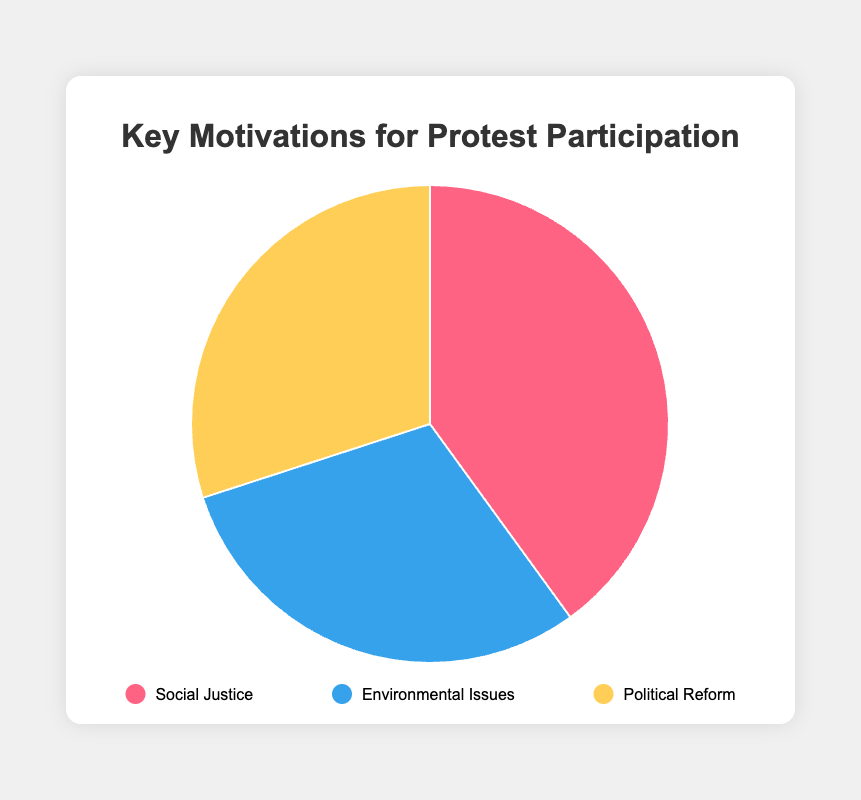Which motivation has the highest percentage? The figure shows three motivations represented by differently sized slices of the pie. The largest slice corresponds to Social Justice with 40%.
Answer: Social Justice What percentage of participants are motivated by Environmental Issues and Political Reform combined? We add the percentages of Environmental Issues (30%) and Political Reform (30%). 30% + 30% = 60%
Answer: 60% Which two motivations have equal percentages? By looking at the pie chart, we can see that the slices for Environmental Issues and Political Reform are the same size, representing equal percentages of 30% each.
Answer: Environmental Issues and Political Reform How much larger is the percentage for Social Justice compared to Environmental Issues? The Social Justice pie slice is 40%, and the Environmental Issues slice is 30%. The difference is 40% - 30% = 10%.
Answer: 10% What is the smallest individual percentage value represented on the chart? The smallest percentages on the chart are for Environmental Issues and Political Reform, both at 30%.
Answer: 30% Which color represents the Political Reform portion of the pie chart? The chart shows color-coded slices, with the Political Reform section being a shade of yellow.
Answer: Yellow What is the average percentage of the three motivations? We find the average by summing the percentages and dividing by the number of data points: (40% + 30% + 30%) / 3 = 100% / 3 ≈ 33.33%.
Answer: 33.33% Compare the combined share of Environmental Issues and Political Reform to Social Justice. Which is larger? Environmental Issues and Political Reform combined is 60%. Social Justice is 40%. 60% > 40%, so the combined percentage is larger.
Answer: Combined share of Environmental Issues and Political Reform 